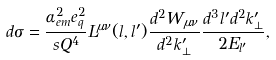Convert formula to latex. <formula><loc_0><loc_0><loc_500><loc_500>d \sigma = \frac { \alpha _ { e m } ^ { 2 } e _ { q } ^ { 2 } } { s Q ^ { 4 } } L ^ { \mu \nu } ( l , l ^ { \prime } ) \frac { d ^ { 2 } W _ { \mu \nu } } { d ^ { 2 } k ^ { \prime } _ { \perp } } \frac { d ^ { 3 } l ^ { \prime } d ^ { 2 } k ^ { \prime } _ { \perp } } { 2 E _ { l ^ { \prime } } } ,</formula> 